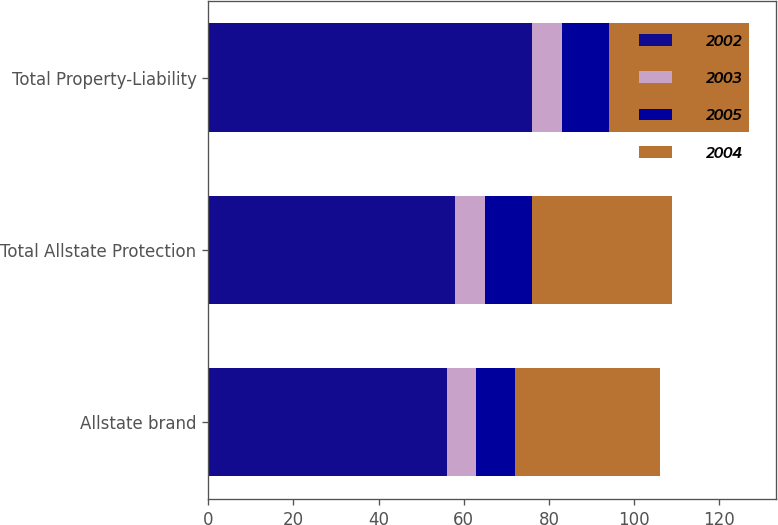Convert chart to OTSL. <chart><loc_0><loc_0><loc_500><loc_500><stacked_bar_chart><ecel><fcel>Allstate brand<fcel>Total Allstate Protection<fcel>Total Property-Liability<nl><fcel>2002<fcel>56<fcel>58<fcel>76<nl><fcel>2003<fcel>7<fcel>7<fcel>7<nl><fcel>2005<fcel>9<fcel>11<fcel>11<nl><fcel>2004<fcel>34<fcel>33<fcel>33<nl></chart> 